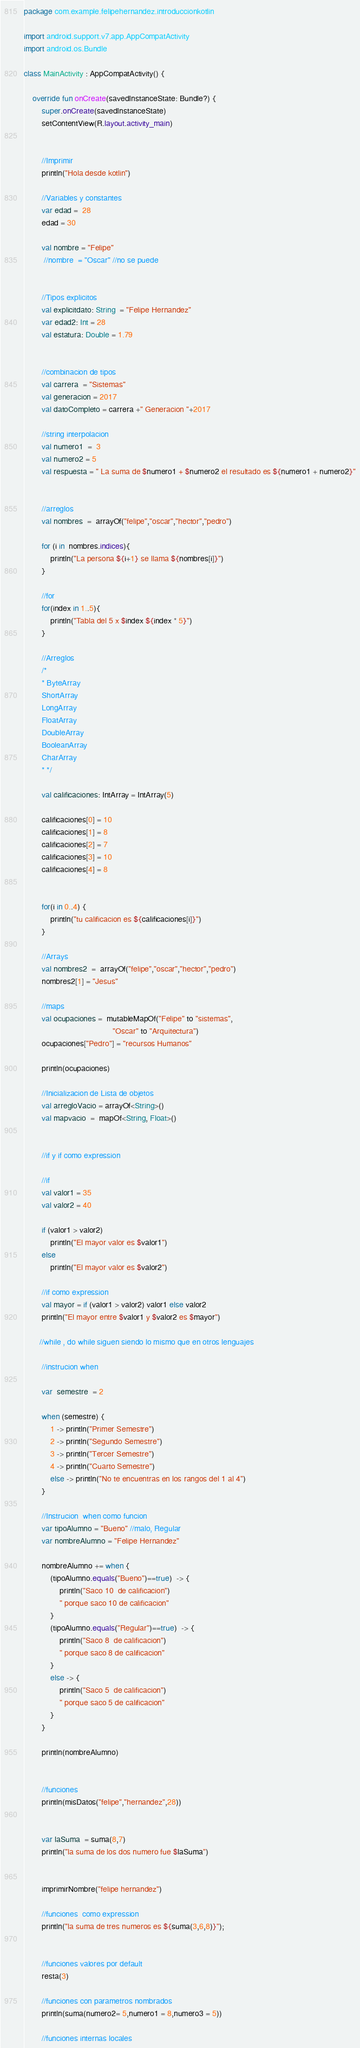<code> <loc_0><loc_0><loc_500><loc_500><_Kotlin_>package com.example.felipehernandez.introduccionkotlin

import android.support.v7.app.AppCompatActivity
import android.os.Bundle

class MainActivity : AppCompatActivity() {

    override fun onCreate(savedInstanceState: Bundle?) {
        super.onCreate(savedInstanceState)
        setContentView(R.layout.activity_main)


        //Imprimir
        println("Hola desde kotlin")

        //Variables y constantes
        var edad =  28
        edad = 30

        val nombre = "Felipe"
         //nombre  = "Oscar" //no se puede


        //Tipos explicitos
        val explicitdato: String  = "Felipe Hernandez"
        var edad2: Int = 28
        val estatura: Double = 1.79


        //combinacion de tipos
        val carrera  = "Sistemas"
        val generacion = 2017
        val datoCompleto = carrera +" Generacion "+2017

        //string interpolacion
        val numero1  =  3
        val numero2 = 5
        val respuesta = " La suma de $numero1 + $numero2 el resultado es ${numero1 + numero2}"


        //arreglos
        val nombres  =  arrayOf("felipe","oscar","hector","pedro")

        for (i in  nombres.indices){
            println("La persona ${i+1} se llama ${nombres[i]}")
        }

        //for
        for(index in 1..5){
            println("Tabla del 5 x $index ${index * 5}")
        }

        //Arreglos
        /*
        * ByteArray
        ShortArray
        LongArray
        FloatArray
        DoubleArray
        BooleanArray
        CharArray
        * */

        val calificaciones: IntArray = IntArray(5)

        calificaciones[0] = 10
        calificaciones[1] = 8
        calificaciones[2] = 7
        calificaciones[3] = 10
        calificaciones[4] = 8


        for(i in 0..4) {
            println("tu calificacion es ${calificaciones[i]}")
        }

        //Arrays
        val nombres2  =  arrayOf("felipe","oscar","hector","pedro")
        nombres2[1] = "Jesus"

        //maps
        val ocupaciones =  mutableMapOf("Felipe" to "sistemas",
                                        "Oscar" to "Arquitectura")
        ocupaciones["Pedro"] = "recursos Humanos"

        println(ocupaciones)

        //Inicializacion de Lista de objetos
        val arregloVacio = arrayOf<String>()
        val mapvacio  =  mapOf<String, Float>()


        //if y if como expression

        //if
        val valor1 = 35
        val valor2 = 40

        if (valor1 > valor2)
            println("El mayor valor es $valor1")
        else
            println("El mayor valor es $valor2")

        //if como expression
        val mayor = if (valor1 > valor2) valor1 else valor2
        println("El mayor entre $valor1 y $valor2 es $mayor")

       //while , do while siguen siendo lo mismo que en otros lenguajes

        //instrucion when

        var  semestre  = 2

        when (semestre) {
            1 -> println("Primer Semestre")
            2 -> println("Segundo Semestre")
            3 -> println("Tercer Semestre")
            4 -> println("Cuarto Semestre")
            else -> println("No te encuentras en los rangos del 1 al 4")
        }

        //Instrucion  when como funcion
        var tipoAlumno = "Bueno" //malo, Regular
        var nombreAlumno = "Felipe Hernandez"

        nombreAlumno += when {
            (tipoAlumno.equals("Bueno")==true)  -> {
                println("Saco 10  de calificacion")
                " porque saco 10 de calificacion"
            }
            (tipoAlumno.equals("Regular")==true)  -> {
                println("Saco 8  de calificacion")
                " porque saco 8 de calificacion"
            }
            else -> {
                println("Saco 5  de calificacion")
                " porque saco 5 de calificacion"
            }
        }

        println(nombreAlumno)


        //funciones
        println(misDatos("felipe","hernandez",28))


        var laSuma  = suma(8,7)
        println("la suma de los dos numero fue $laSuma")


        imprimirNombre("felipe hernandez")

        //funciones  como expression
        println("la suma de tres numeros es ${suma(3,6,8)}");


        //funciones valores por default
        resta(3)

        //funciones con parametros nombrados
        println(suma(numero2= 5,numero1 = 8,numero3 = 5))

        //funciones internas locales</code> 